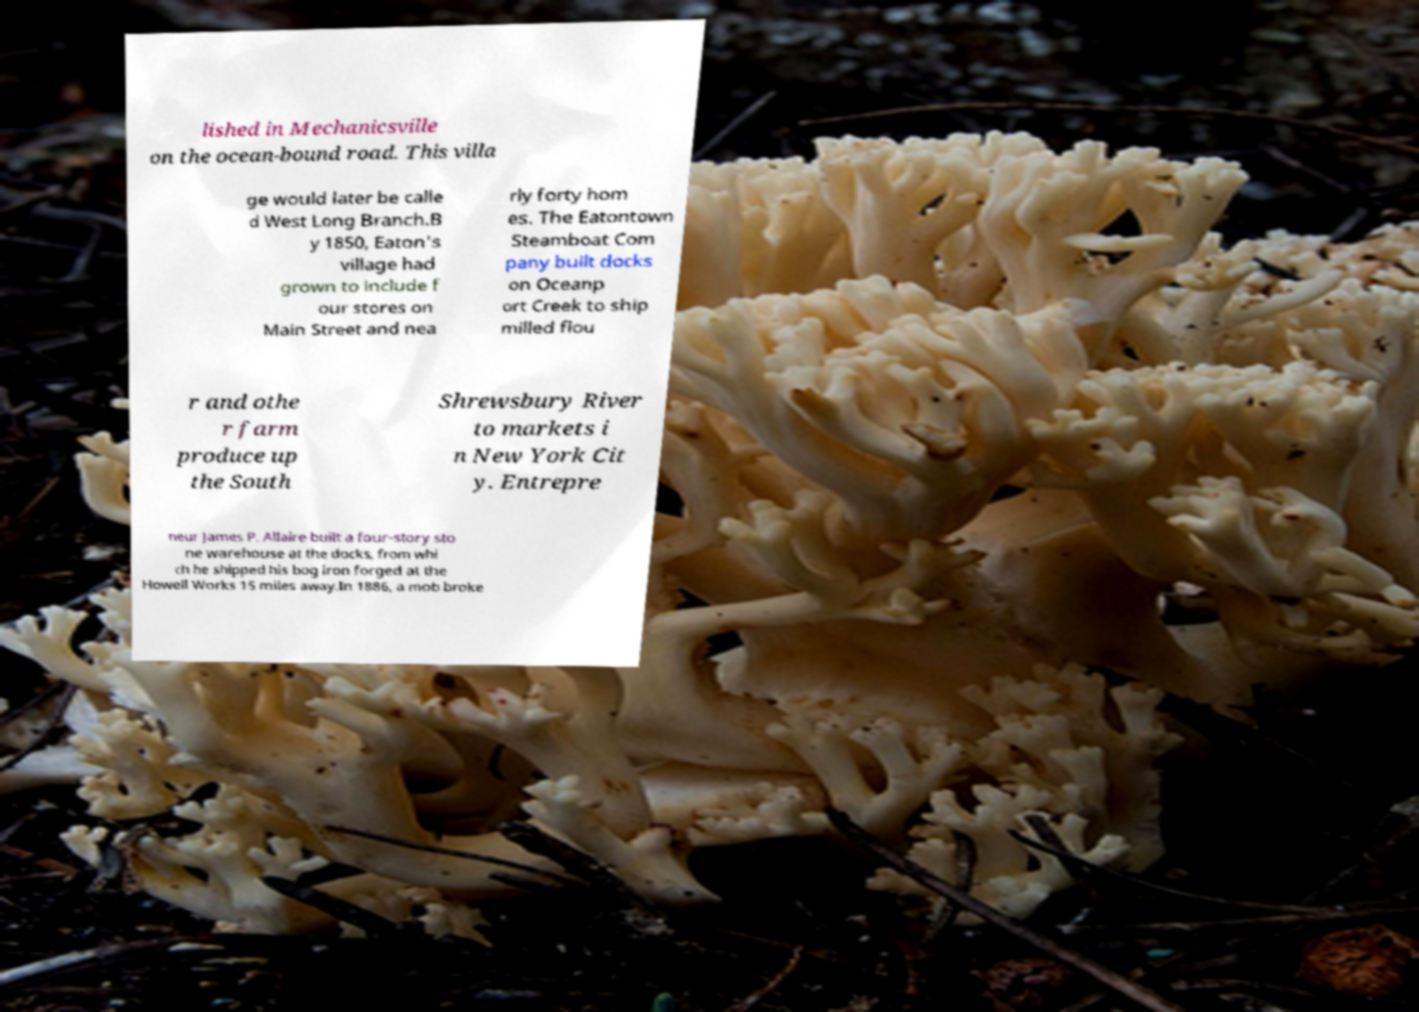I need the written content from this picture converted into text. Can you do that? lished in Mechanicsville on the ocean-bound road. This villa ge would later be calle d West Long Branch.B y 1850, Eaton's village had grown to include f our stores on Main Street and nea rly forty hom es. The Eatontown Steamboat Com pany built docks on Oceanp ort Creek to ship milled flou r and othe r farm produce up the South Shrewsbury River to markets i n New York Cit y. Entrepre neur James P. Allaire built a four-story sto ne warehouse at the docks, from whi ch he shipped his bog iron forged at the Howell Works 15 miles away.In 1886, a mob broke 